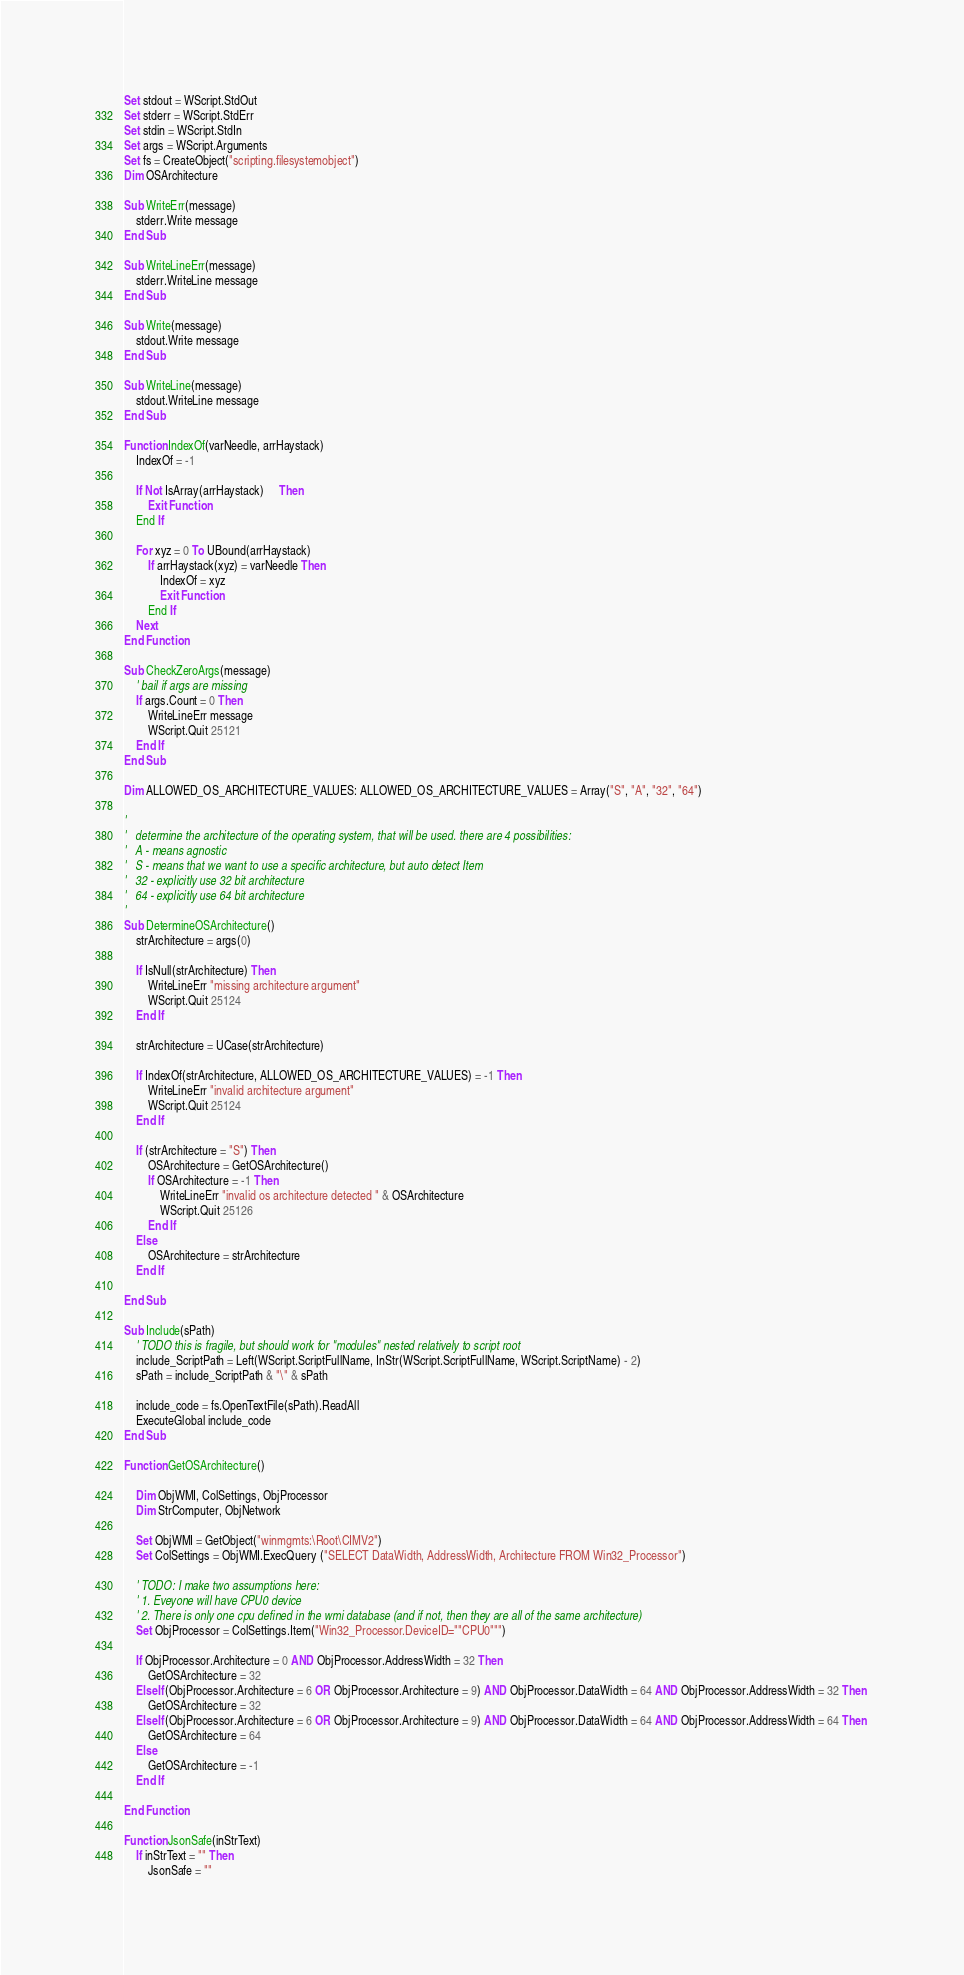Convert code to text. <code><loc_0><loc_0><loc_500><loc_500><_VisualBasic_>Set stdout = WScript.StdOut
Set stderr = WScript.StdErr
Set stdin = WScript.StdIn
Set args = WScript.Arguments
Set fs = CreateObject("scripting.filesystemobject") 
Dim OSArchitecture

Sub WriteErr(message)
	stderr.Write message
End Sub

Sub WriteLineErr(message)
	stderr.WriteLine message
End Sub

Sub Write(message)
	stdout.Write message
End Sub

Sub WriteLine(message)
	stdout.WriteLine message
End Sub

Function IndexOf(varNeedle, arrHaystack)
	IndexOf = -1
	
	If Not IsArray(arrHaystack)	 Then
		Exit Function
	End If

	For xyz = 0 To UBound(arrHaystack)
		If arrHaystack(xyz) = varNeedle Then
			IndexOf = xyz
			Exit Function
		End If
	Next
End Function

Sub CheckZeroArgs(message)
	' bail if args are missing
	If args.Count = 0 Then
		WriteLineErr message
		WScript.Quit 25121
	End If
End Sub

Dim ALLOWED_OS_ARCHITECTURE_VALUES: ALLOWED_OS_ARCHITECTURE_VALUES = Array("S", "A", "32", "64")

'
'	determine the architecture of the operating system, that will be used. there are 4 possibilities:
'	A - means agnostic
'	S - means that we want to use a specific architecture, but auto detect Item
'	32 - explicitly use 32 bit architecture
'	64 - explicitly use 64 bit architecture
'
Sub DetermineOSArchitecture()
	strArchitecture = args(0)

	If IsNull(strArchitecture) Then
		WriteLineErr "missing architecture argument"
		WScript.Quit 25124
	End If

	strArchitecture = UCase(strArchitecture)

	If IndexOf(strArchitecture, ALLOWED_OS_ARCHITECTURE_VALUES) = -1 Then
		WriteLineErr "invalid architecture argument"
		WScript.Quit 25124
	End If

	If (strArchitecture = "S") Then
		OSArchitecture = GetOSArchitecture()
		If OSArchitecture = -1 Then
			WriteLineErr "invalid os architecture detected " & OSArchitecture
			WScript.Quit 25126
		End If
	Else
		OSArchitecture = strArchitecture
	End If

End Sub

Sub Include(sPath)
	' TODO this is fragile, but should work for "modules" nested relatively to script root
	include_ScriptPath = Left(WScript.ScriptFullName, InStr(WScript.ScriptFullName, WScript.ScriptName) - 2)	
	sPath = include_ScriptPath & "\" & sPath
	
	include_code = fs.OpenTextFile(sPath).ReadAll 	
	ExecuteGlobal include_code
End Sub

Function GetOSArchitecture()

	Dim ObjWMI, ColSettings, ObjProcessor 
	Dim StrComputer, ObjNetwork 
	
	Set ObjWMI = GetObject("winmgmts:\Root\CIMV2") 
	Set ColSettings = ObjWMI.ExecQuery ("SELECT DataWidth, AddressWidth, Architecture FROM Win32_Processor") 

	' TODO: I make two assumptions here: 
	' 1. Eveyone will have CPU0 device
	' 2. There is only one cpu defined in the wmi database (and if not, then they are all of the same architecture)
	Set ObjProcessor = ColSettings.Item("Win32_Processor.DeviceID=""CPU0""")

	If ObjProcessor.Architecture = 0 AND ObjProcessor.AddressWidth = 32 Then 
		GetOSArchitecture = 32
	ElseIf (ObjProcessor.Architecture = 6 OR ObjProcessor.Architecture = 9) AND ObjProcessor.DataWidth = 64 AND ObjProcessor.AddressWidth = 32 Then 
		GetOSArchitecture = 32
	ElseIf (ObjProcessor.Architecture = 6 OR ObjProcessor.Architecture = 9) AND ObjProcessor.DataWidth = 64 AND ObjProcessor.AddressWidth = 64 Then 
		GetOSArchitecture = 64
	Else		
		GetOSArchitecture = -1
	End If 
	
End Function

Function JsonSafe(inStrText)
	If inStrText = "" Then
		JsonSafe = ""</code> 